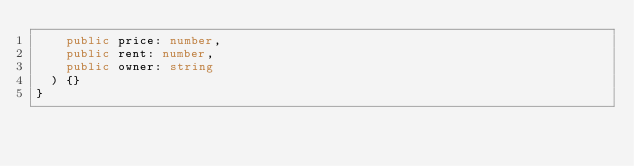Convert code to text. <code><loc_0><loc_0><loc_500><loc_500><_TypeScript_>    public price: number,
    public rent: number,
    public owner: string
  ) {}
}
</code> 